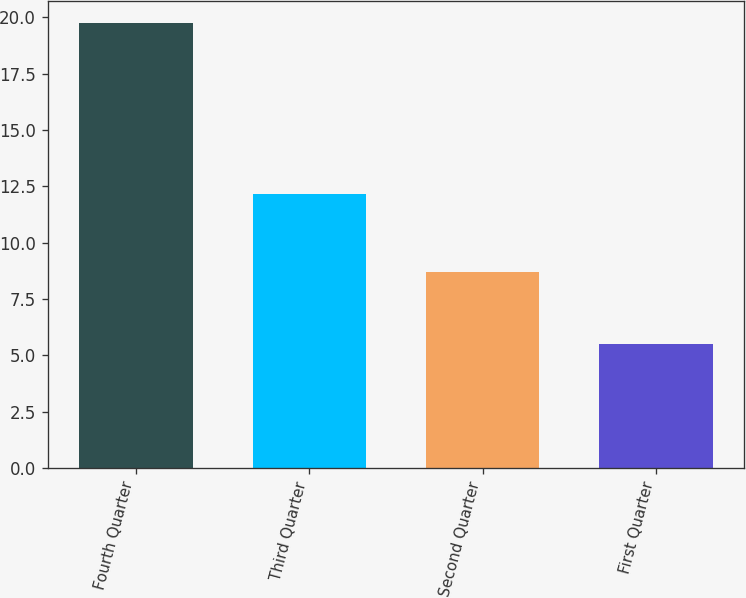Convert chart to OTSL. <chart><loc_0><loc_0><loc_500><loc_500><bar_chart><fcel>Fourth Quarter<fcel>Third Quarter<fcel>Second Quarter<fcel>First Quarter<nl><fcel>19.75<fcel>12.16<fcel>8.69<fcel>5.5<nl></chart> 